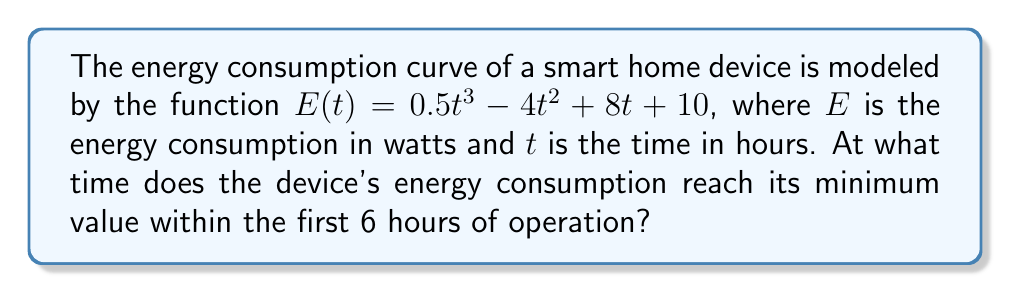Show me your answer to this math problem. To find the minimum value of the energy consumption, we need to follow these steps:

1) First, we need to find the derivative of the energy consumption function:
   $$E'(t) = \frac{d}{dt}(0.5t^3 - 4t^2 + 8t + 10) = 1.5t^2 - 8t + 8$$

2) To find the critical points, we set the derivative equal to zero:
   $$E'(t) = 1.5t^2 - 8t + 8 = 0$$

3) This is a quadratic equation. We can solve it using the quadratic formula:
   $$t = \frac{-b \pm \sqrt{b^2 - 4ac}}{2a}$$
   where $a = 1.5$, $b = -8$, and $c = 8$

4) Plugging in these values:
   $$t = \frac{8 \pm \sqrt{64 - 48}}{3} = \frac{8 \pm 4}{3}$$

5) This gives us two critical points:
   $$t_1 = \frac{8 + 4}{3} = 4$$ and $$t_2 = \frac{8 - 4}{3} = \frac{4}{3}$$

6) To determine which of these is a minimum, we can use the second derivative test:
   $$E''(t) = 3t - 8$$

7) Evaluating $E''(t)$ at our critical points:
   $$E''(4) = 3(4) - 8 = 4 > 0$$
   $$E''(\frac{4}{3}) = 3(\frac{4}{3}) - 8 = -4 < 0$$

8) Since $E''(4) > 0$, $t = 4$ is a local minimum.
   Since $E''(\frac{4}{3}) < 0$, $t = \frac{4}{3}$ is a local maximum.

9) Therefore, within the first 6 hours, the minimum occurs at $t = 4$ hours.
Answer: 4 hours 